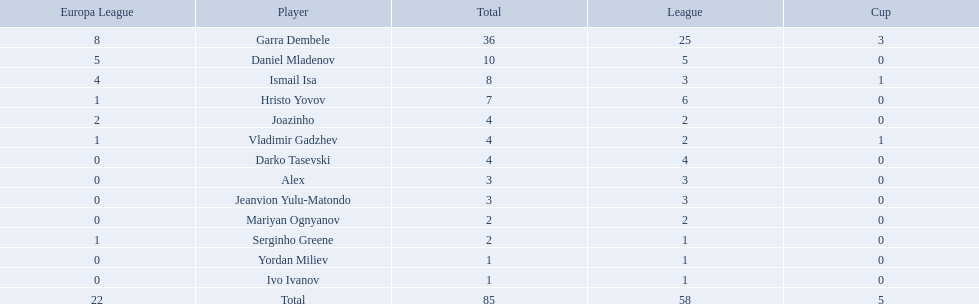What league is 2? 2, 2, 2. Which cup is less than 1? 0, 0. Which total is 2? 2. Who is the player? Mariyan Ognyanov. 